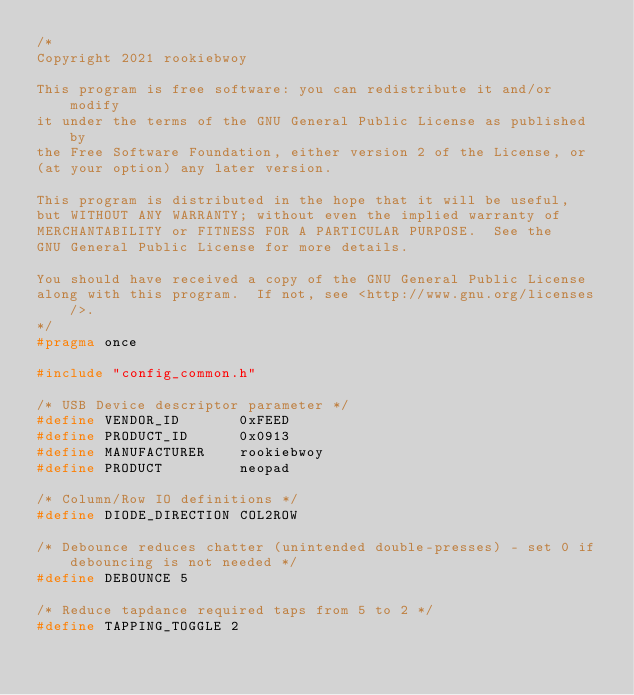<code> <loc_0><loc_0><loc_500><loc_500><_C_>/*
Copyright 2021 rookiebwoy

This program is free software: you can redistribute it and/or modify
it under the terms of the GNU General Public License as published by
the Free Software Foundation, either version 2 of the License, or
(at your option) any later version.

This program is distributed in the hope that it will be useful,
but WITHOUT ANY WARRANTY; without even the implied warranty of
MERCHANTABILITY or FITNESS FOR A PARTICULAR PURPOSE.  See the
GNU General Public License for more details.

You should have received a copy of the GNU General Public License
along with this program.  If not, see <http://www.gnu.org/licenses/>.
*/
#pragma once

#include "config_common.h"

/* USB Device descriptor parameter */
#define VENDOR_ID       0xFEED
#define PRODUCT_ID      0x0913
#define MANUFACTURER    rookiebwoy
#define PRODUCT         neopad

/* Column/Row IO definitions */
#define DIODE_DIRECTION COL2ROW

/* Debounce reduces chatter (unintended double-presses) - set 0 if debouncing is not needed */
#define DEBOUNCE 5

/* Reduce tapdance required taps from 5 to 2 */
#define TAPPING_TOGGLE 2
</code> 